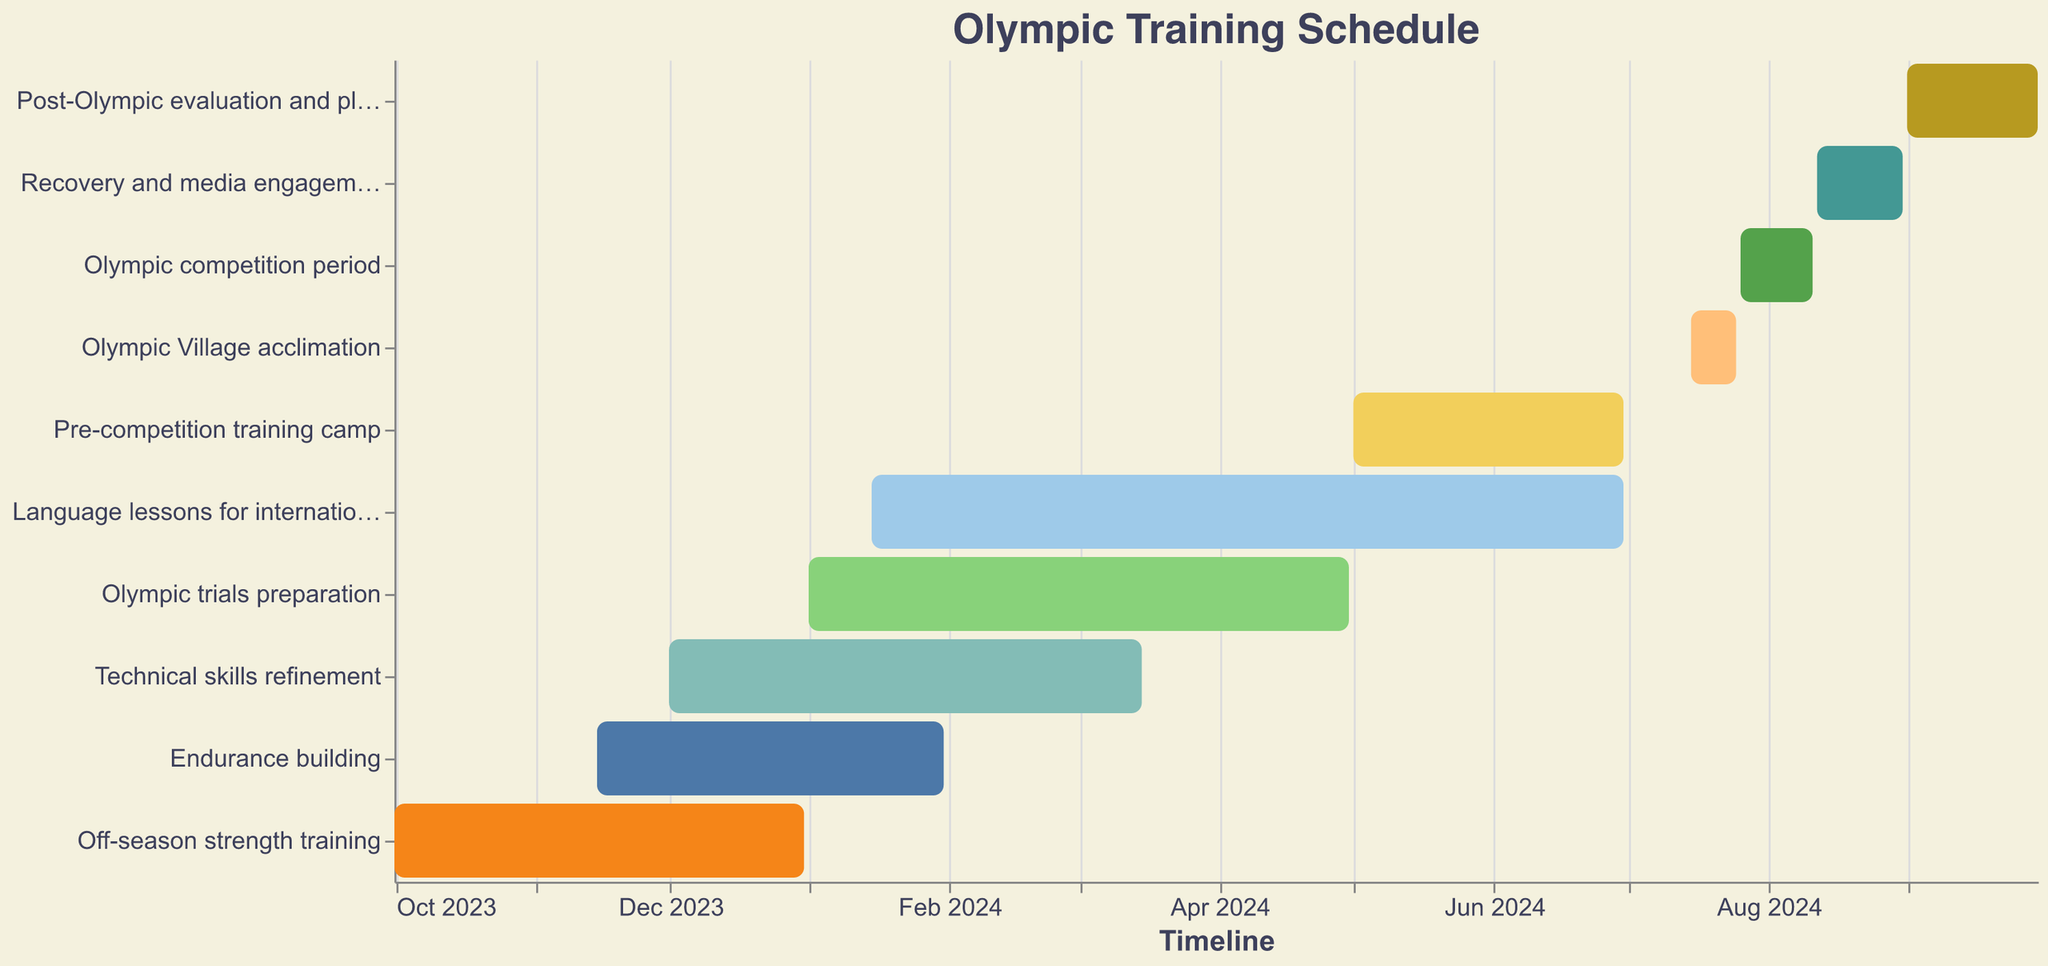When does the off-season strength training begin? Look for the "Off-season strength training" bar on the y-axis and check the start date on the x-axis.
Answer: October 1, 2023 How long does the endurance building phase last? Find the "Endurance building" bar and calculate the duration between its start date (November 15, 2023) and its end date (January 31, 2024).
Answer: 2.5 months Which task overlaps entirely with the Olympic trials preparation? Identify the tasks and compare their dates with "Olympic trials preparation" (January 1, 2024 to April 30, 2024). "Technical skills refinement" completely overlaps during this period.
Answer: Technical skills refinement What is the shortest task duration during the training schedule? Examine all bars and compare their lengths. The shortest is "Olympic Village acclimation" (July 15, 2024 to July 25, 2024).
Answer: 10 days Which phase immediately follows the Olympic competition period? Check the end date of the "Olympic competition period" (August 11, 2024) and the start date of subsequent tasks. "Recovery and media engagements" starts on August 12, 2024.
Answer: Recovery and media engagements How many months are allocated to language lessons for international communication? Calculate the duration from its start date (January 15, 2024) to its end date (June 30, 2024).
Answer: 5.5 months Do endurance building and technical skills refinement overlap in time? Compare their periods: "Endurance building" (November 15, 2023 to January 31, 2024) and "Technical skills refinement" (December 1, 2023 to March 15, 2024).
Answer: Yes What phase has the longest duration in the training schedule? Compare the lengths of all bars. "Language lessons for international communication" spans from January 15, 2024, to June 30, 2024.
Answer: Language lessons for international communication How many phases occur after the pre-competition training camp? Identify the "Pre-competition training camp" (ending June 30, 2024) and count subsequent tasks.
Answer: Four What is the end date of the post-Olympic evaluation and planning phase? Observe the bar for "Post-Olympic evaluation and planning" and note its end date.
Answer: September 30, 2024 